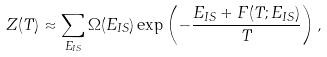Convert formula to latex. <formula><loc_0><loc_0><loc_500><loc_500>Z ( T ) \approx \sum _ { E _ { I S } } \Omega ( E _ { I S } ) \exp \left ( - \frac { E _ { I S } + F ( T ; E _ { I S } ) } { T } \right ) ,</formula> 